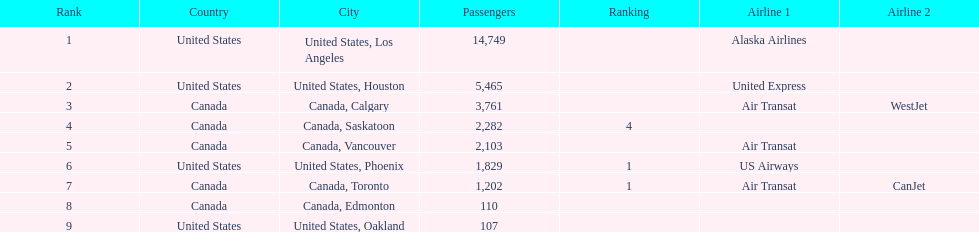How many airlines have a steady ranking? 4. 